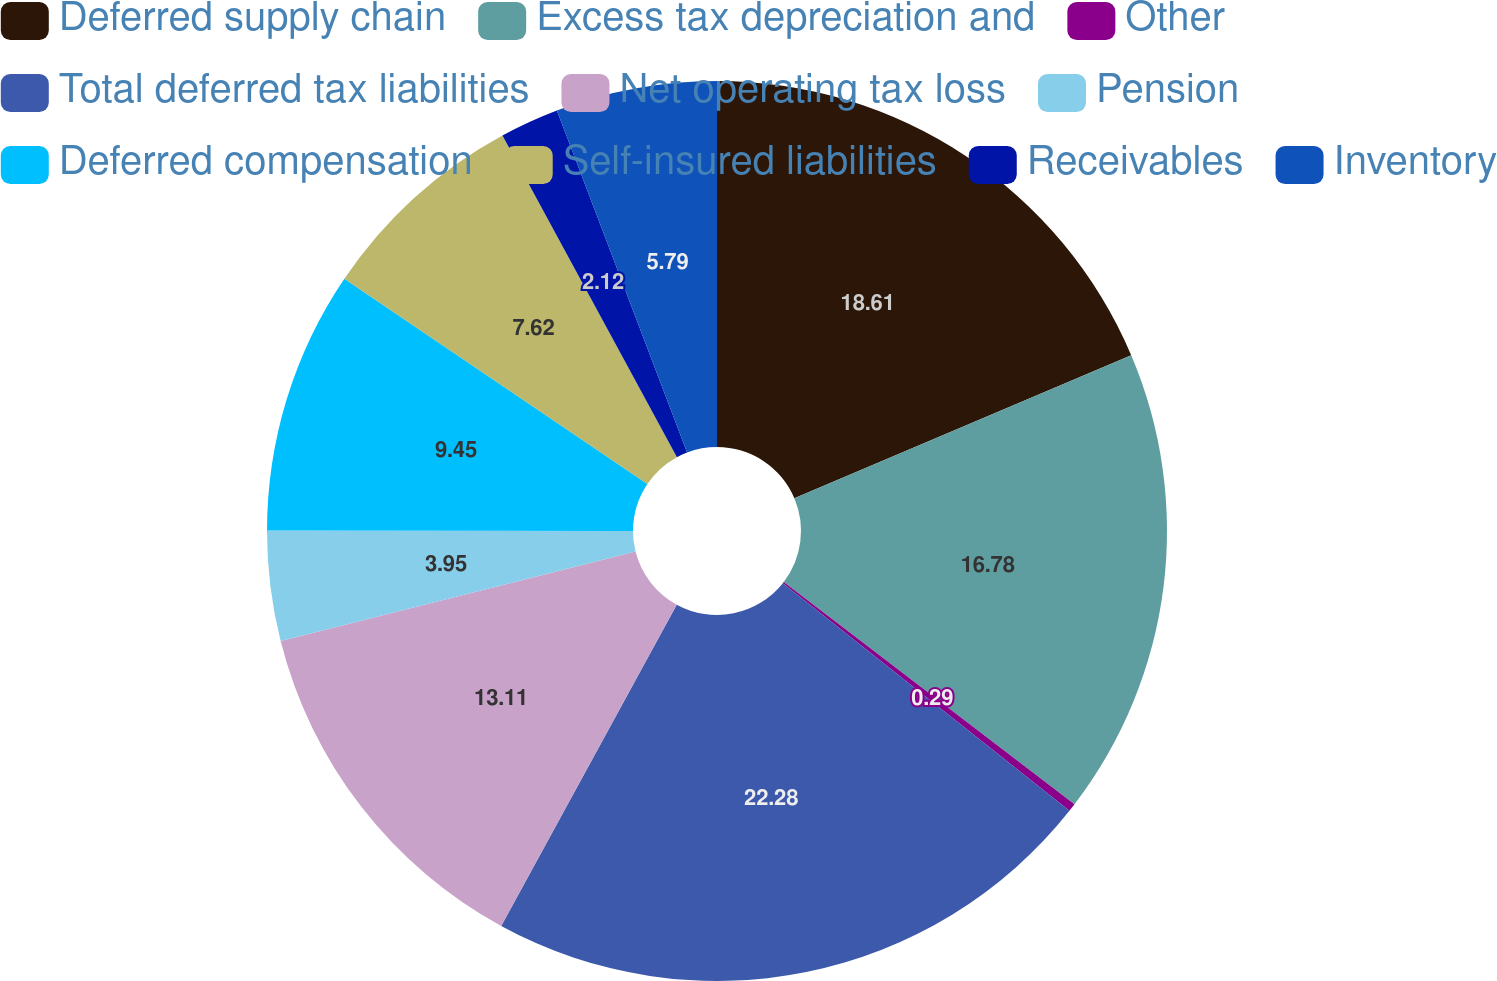Convert chart to OTSL. <chart><loc_0><loc_0><loc_500><loc_500><pie_chart><fcel>Deferred supply chain<fcel>Excess tax depreciation and<fcel>Other<fcel>Total deferred tax liabilities<fcel>Net operating tax loss<fcel>Pension<fcel>Deferred compensation<fcel>Self-insured liabilities<fcel>Receivables<fcel>Inventory<nl><fcel>18.61%<fcel>16.78%<fcel>0.29%<fcel>22.28%<fcel>13.11%<fcel>3.95%<fcel>9.45%<fcel>7.62%<fcel>2.12%<fcel>5.79%<nl></chart> 